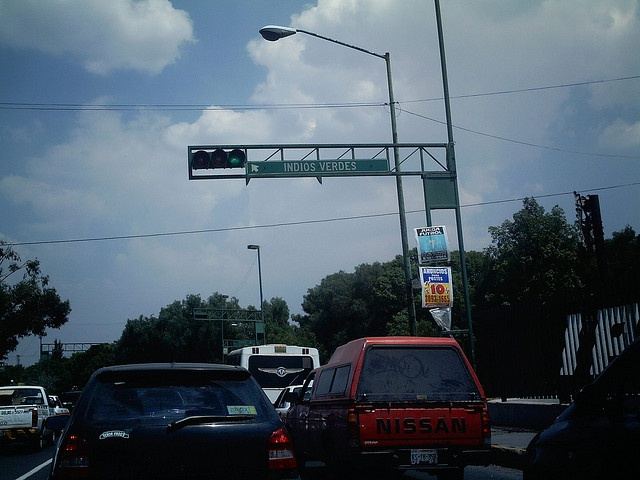Describe the objects in this image and their specific colors. I can see car in teal, black, navy, gray, and blue tones, truck in gray, black, and maroon tones, car in teal, black, navy, gray, and darkblue tones, bus in teal, black, darkgray, gray, and lightgray tones, and truck in teal, black, gray, and blue tones in this image. 